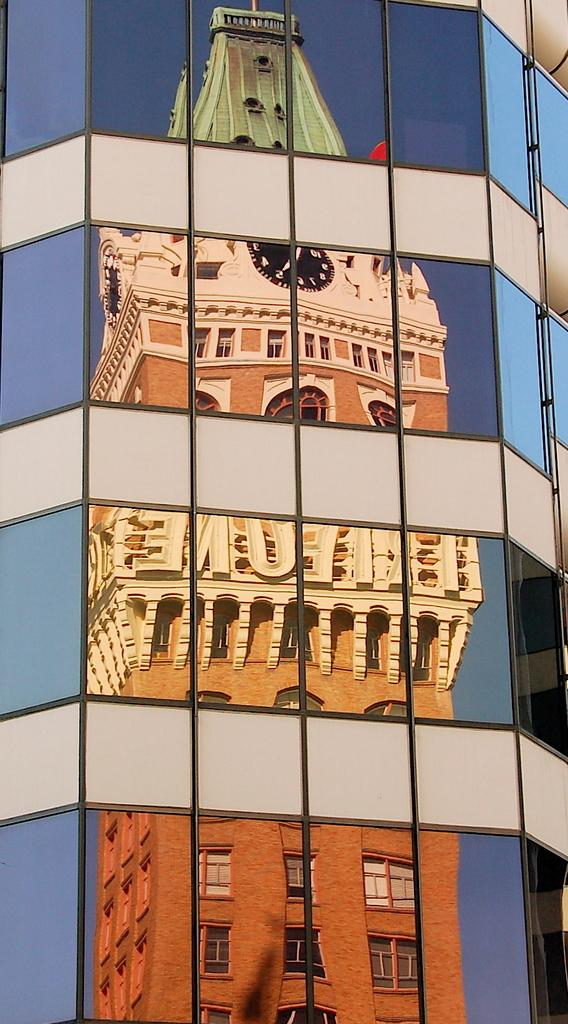What is the main subject in the center of the image? There is a building with glasses in the center of the image. What feature can be observed on the building? The building has a reflection of a tower. Can you see a snake slithering around the building in the image? No, there is no snake present in the image. 